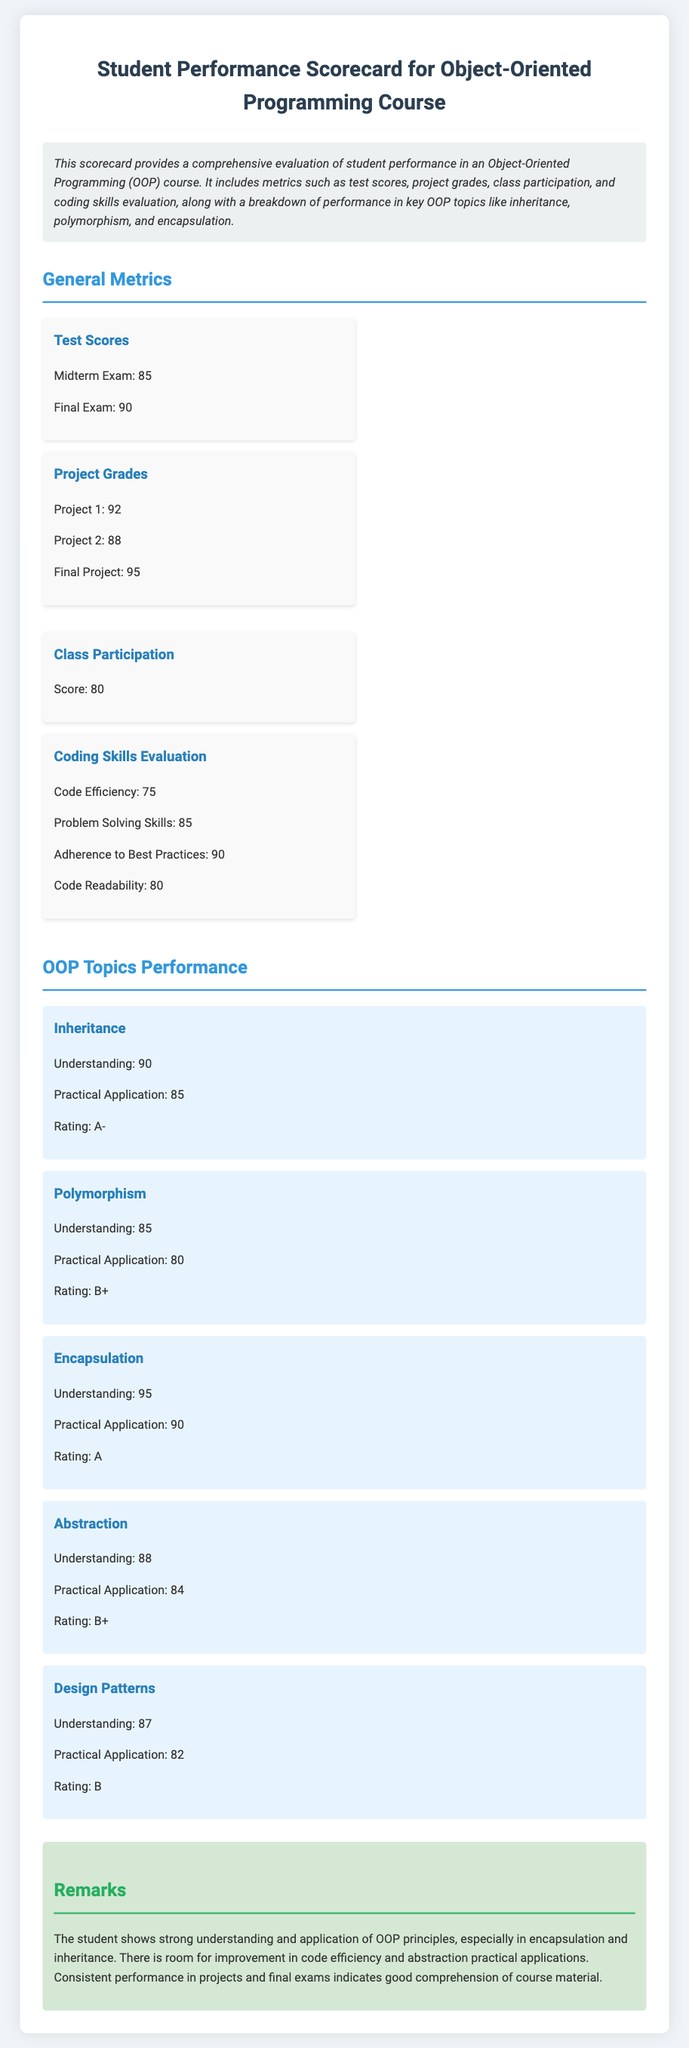What is the midterm exam score? The midterm exam score is listed under test scores in the document.
Answer: 85 What is the final project grade? The final project grade can be found in the project grades section of the scorecard.
Answer: 95 What is the class participation score? The class participation score is clearly stated under general metrics in the document.
Answer: 80 What is the understanding rating for encapsulation? The understanding rating for encapsulation is evident in the OOP topics performance section.
Answer: 95 Which topic has the lowest practical application score? The topic with the lowest practical application score requires comparison of the scores in the OOP topics performance section.
Answer: Design Patterns What rating corresponds to inheritance performance? The rating for inheritance performance is found under the corresponding topic section in the document.
Answer: A- What two areas show room for improvement? These areas can be identified by analyzing the remarks section for specific performance insights.
Answer: Code efficiency and abstraction practical applications What overall impression does the remarks section give about the student's performance? This impression is summarized in the remarks about the student's strengths and weaknesses from the provided text.
Answer: Strong understanding What is the score for problem-solving skills in coding skills evaluation? The score for problem-solving skills is included in the coding skills evaluation section.
Answer: 85 